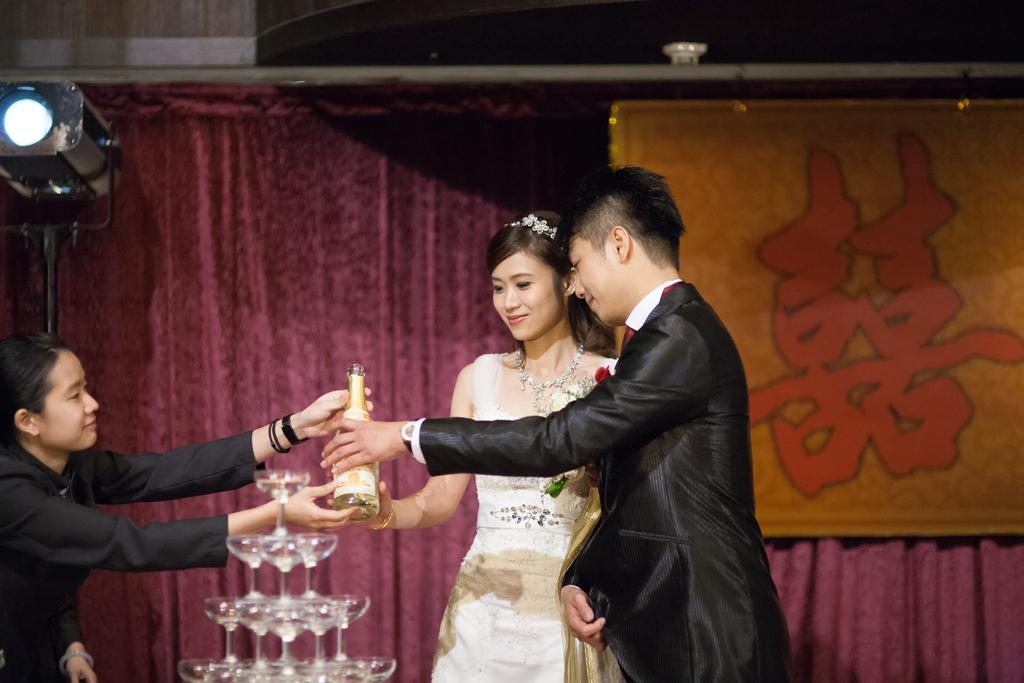Who are the main subjects in the image? There is a bride couple in the image. What are the bride couple holding in the image? The bride couple is holding a wine bottle. What objects are in front of the bride couple? There are wine glasses in front of the bride couple. Can you describe the woman on the left side of the image? There is a woman in a black dress on the left side of the image. What can be seen on the wall behind the bride couple? There is a curtain on the wall behind the bride couple. How many toes can be seen on the bride's feet in the image? There is no visible bride's feet in the image, so it is not possible to determine the number of toes. 